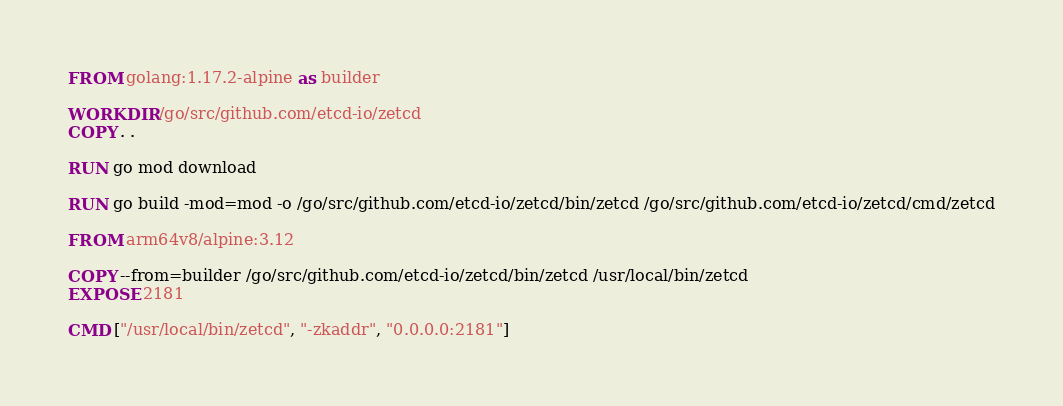<code> <loc_0><loc_0><loc_500><loc_500><_Dockerfile_>FROM golang:1.17.2-alpine as builder

WORKDIR /go/src/github.com/etcd-io/zetcd
COPY . .

RUN go mod download

RUN go build -mod=mod -o /go/src/github.com/etcd-io/zetcd/bin/zetcd /go/src/github.com/etcd-io/zetcd/cmd/zetcd

FROM arm64v8/alpine:3.12

COPY --from=builder /go/src/github.com/etcd-io/zetcd/bin/zetcd /usr/local/bin/zetcd
EXPOSE 2181

CMD ["/usr/local/bin/zetcd", "-zkaddr", "0.0.0.0:2181"]
</code> 